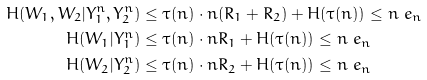<formula> <loc_0><loc_0><loc_500><loc_500>H ( W _ { 1 } , W _ { 2 } | Y _ { 1 } ^ { n } , Y _ { 2 } ^ { n } ) & \leq \tau ( n ) \cdot n ( R _ { 1 } + R _ { 2 } ) + H ( \tau ( n ) ) \leq n \ e _ { n } \\ H ( W _ { 1 } | Y _ { 1 } ^ { n } ) & \leq \tau ( n ) \cdot n R _ { 1 } + H ( \tau ( n ) ) \leq n \ e _ { n } \\ H ( W _ { 2 } | Y _ { 2 } ^ { n } ) & \leq \tau ( n ) \cdot n R _ { 2 } + H ( \tau ( n ) ) \leq n \ e _ { n }</formula> 